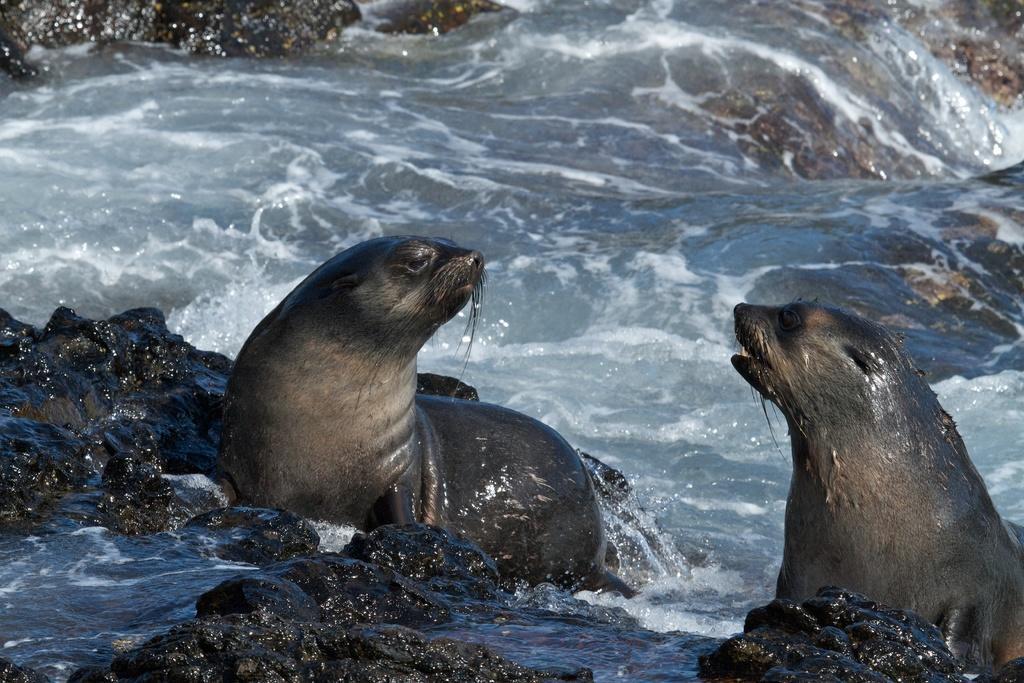Please provide a concise description of this image. In this picture we can see two seals, rocks and in the background we can see water. 